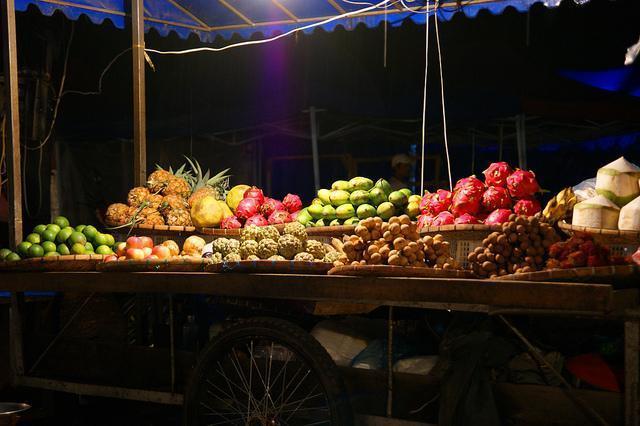How many people are kneeling in the grass?
Give a very brief answer. 0. 